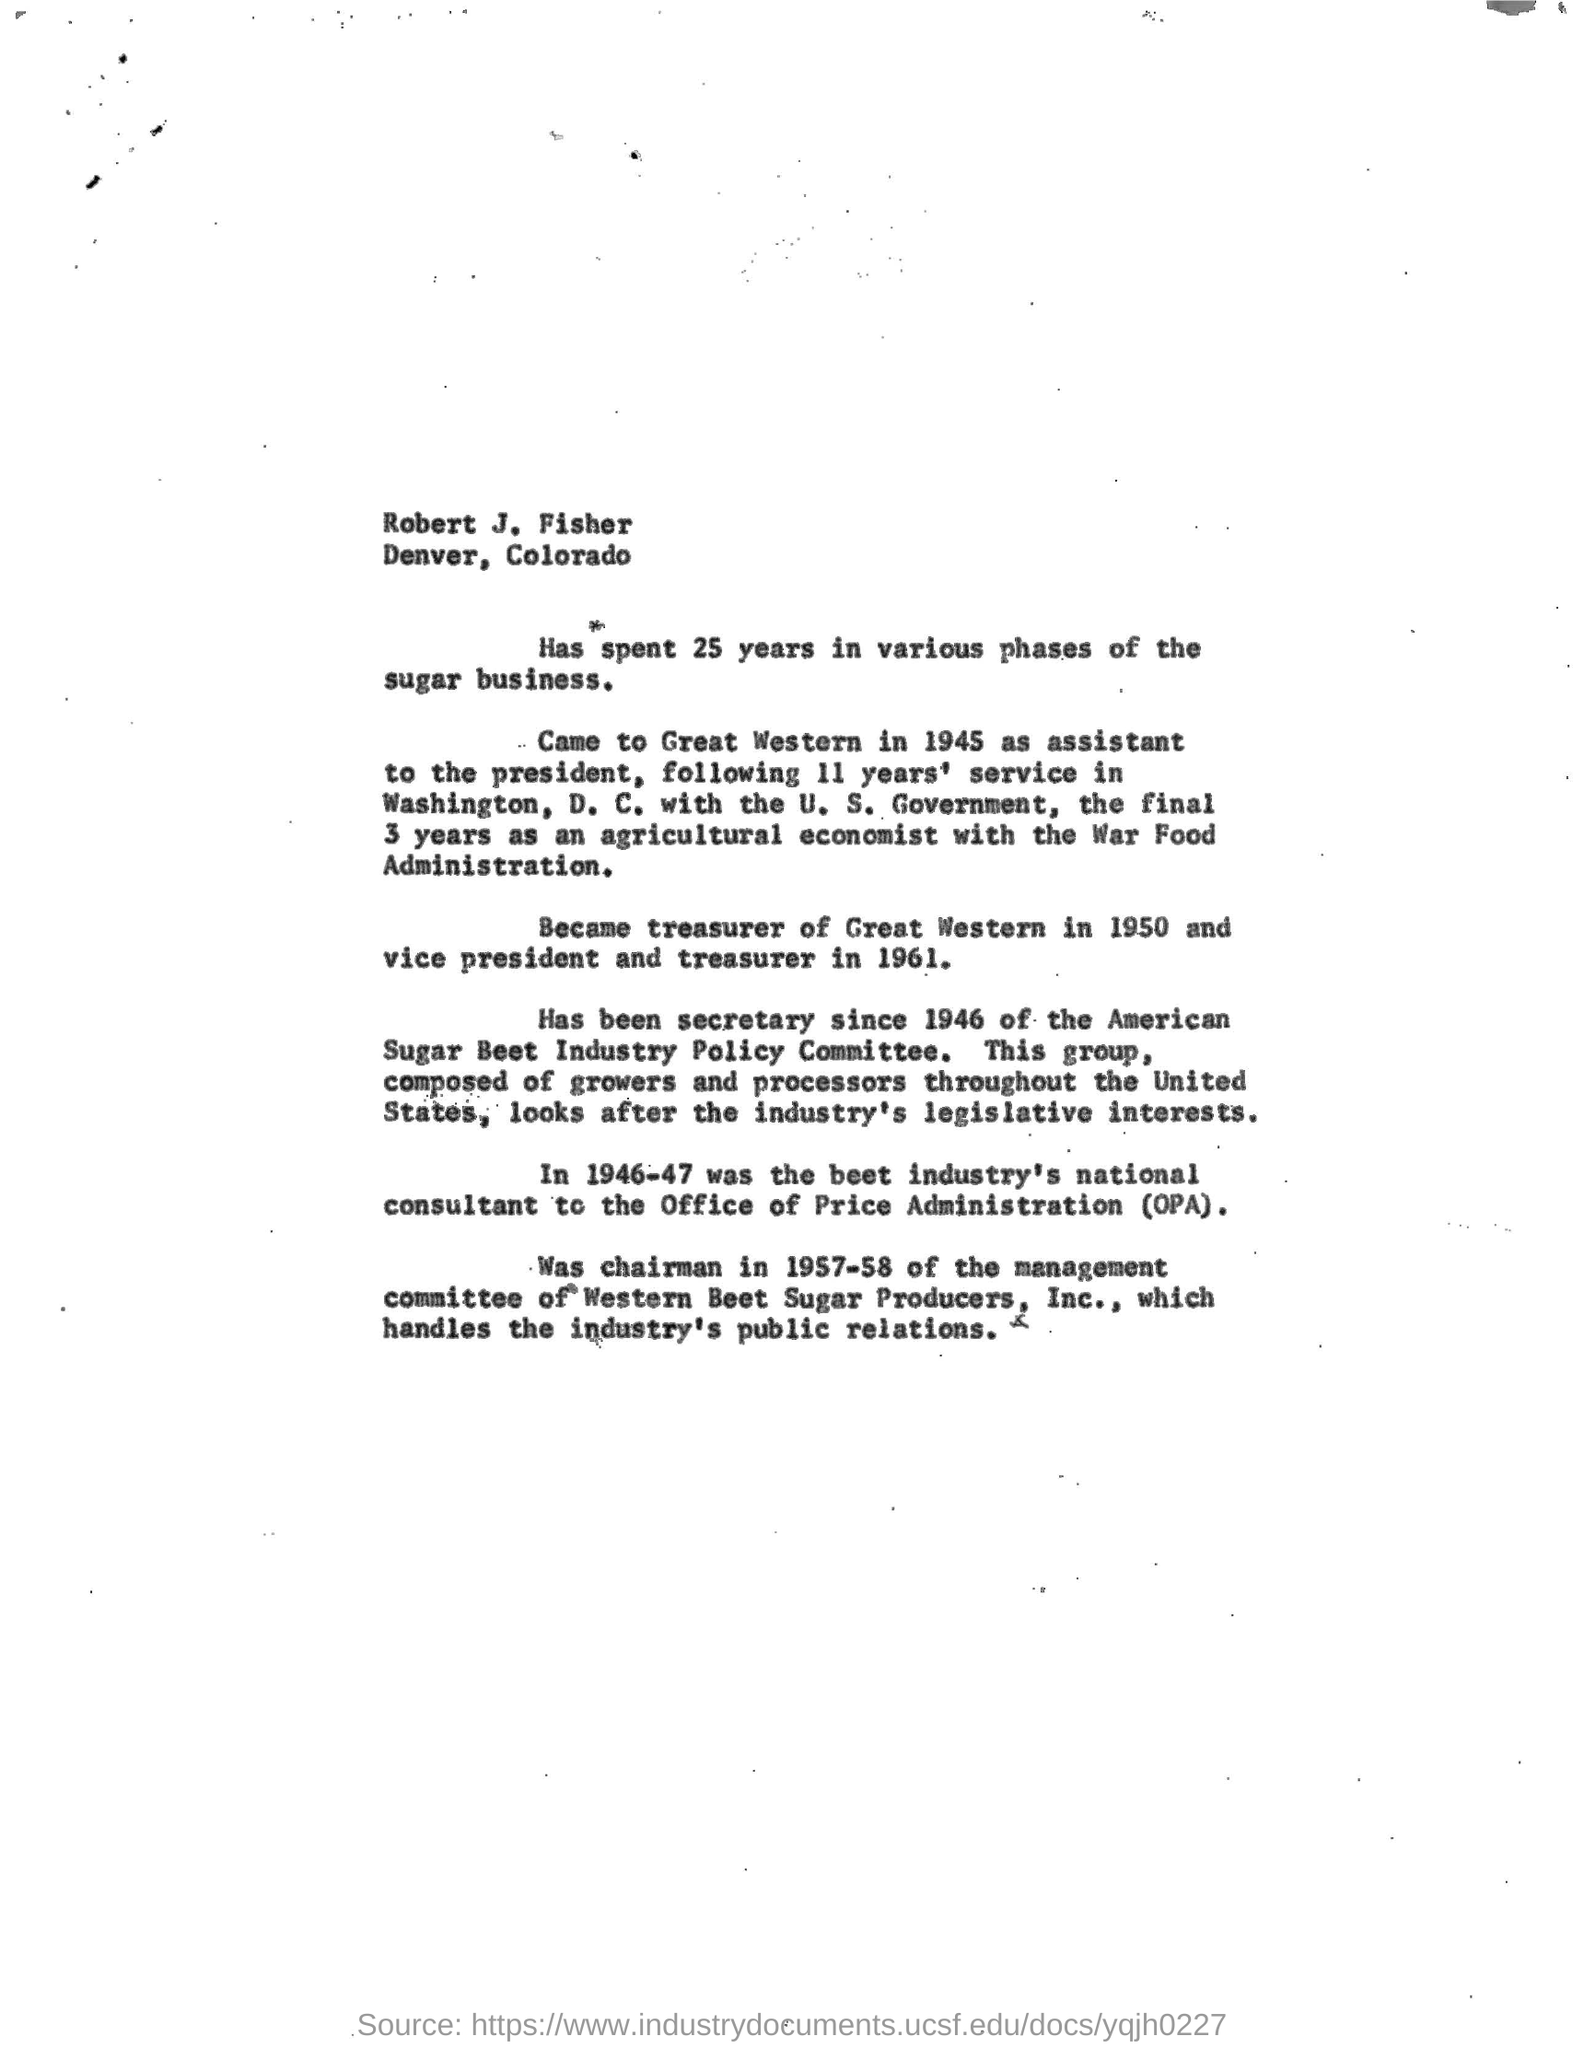Identify some key points in this picture. In 1957-58, Fred H. Merrill served as the chairman of the management committee of Western Beet Sugar Producer, Inc. Robert J. Fisher spent a total of 25 years in various phases of the sugar business. I have worked for the War Food Administration for the past three years as an agricultural economist, serving under which administration? Robert J. Fisher became the national consultant for the beet industry's Office of Price Administration during the administration of [blank]. As the chairman of the management committee of Western Beet Sugar Producer, Inc., I am responsible for handling the public relations of the industry. 